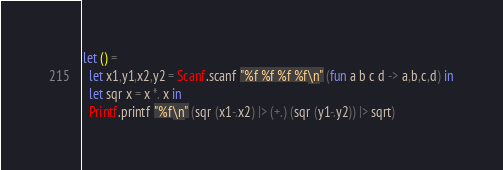<code> <loc_0><loc_0><loc_500><loc_500><_OCaml_>let () =
  let x1,y1,x2,y2 = Scanf.scanf "%f %f %f %f\n" (fun a b c d -> a,b,c,d) in
  let sqr x = x *. x in
  Printf.printf "%f\n" (sqr (x1-.x2) |> (+.) (sqr (y1-.y2)) |> sqrt)</code> 